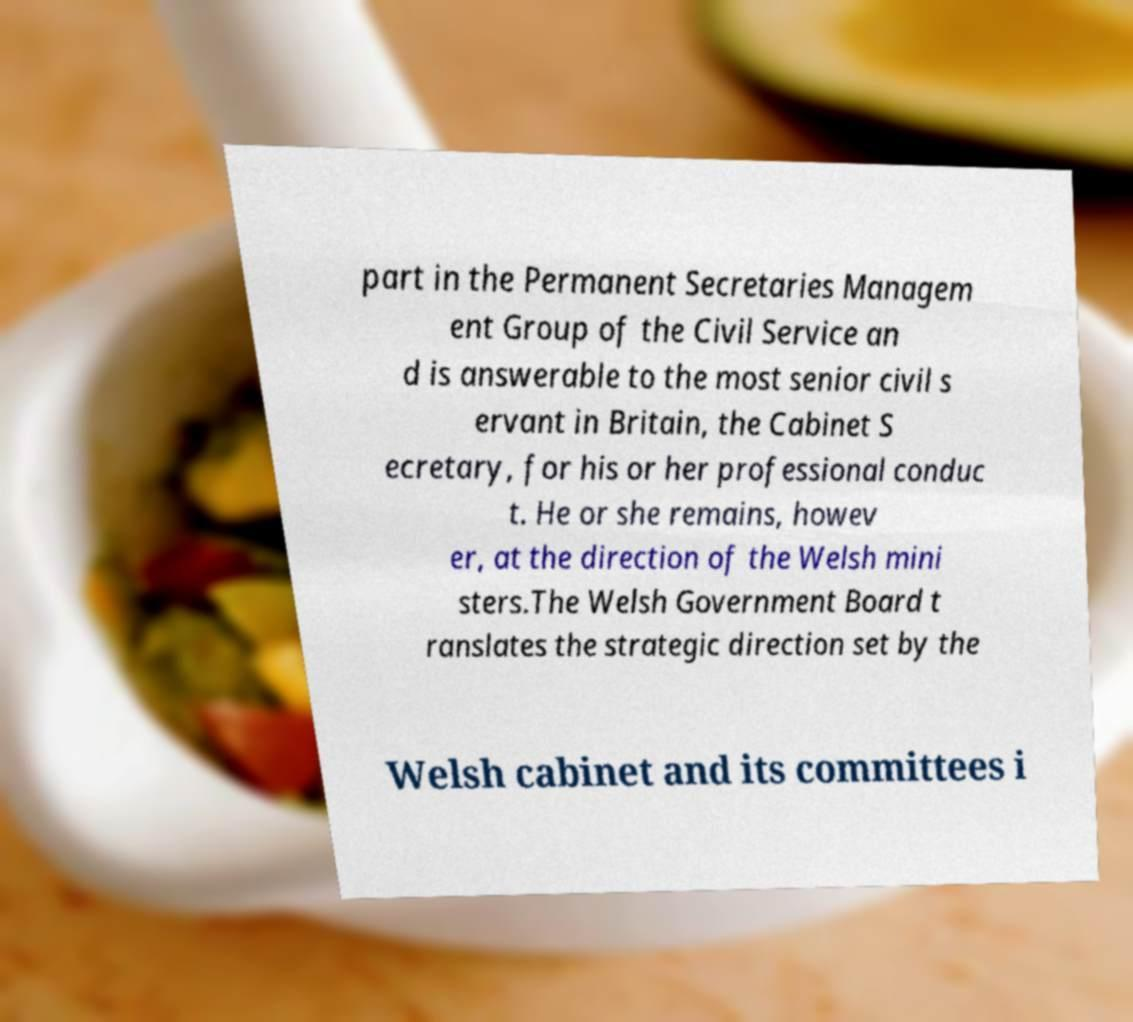I need the written content from this picture converted into text. Can you do that? part in the Permanent Secretaries Managem ent Group of the Civil Service an d is answerable to the most senior civil s ervant in Britain, the Cabinet S ecretary, for his or her professional conduc t. He or she remains, howev er, at the direction of the Welsh mini sters.The Welsh Government Board t ranslates the strategic direction set by the Welsh cabinet and its committees i 